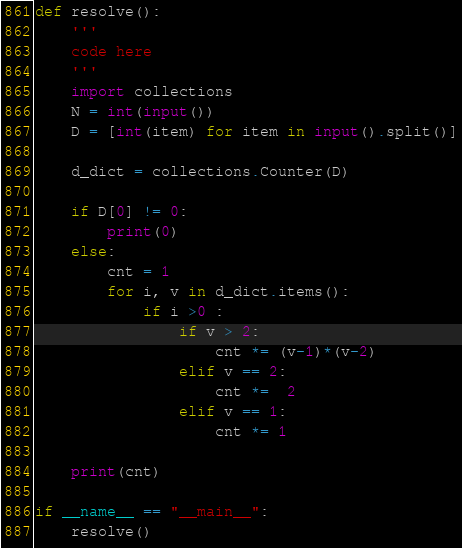<code> <loc_0><loc_0><loc_500><loc_500><_Python_>def resolve():
    '''
    code here
    '''
    import collections
    N = int(input())
    D = [int(item) for item in input().split()]

    d_dict = collections.Counter(D)

    if D[0] != 0:
        print(0)
    else:
        cnt = 1
        for i, v in d_dict.items():
            if i >0 :
                if v > 2:
                    cnt *= (v-1)*(v-2)
                elif v == 2:
                    cnt *=  2
                elif v == 1:
                    cnt *= 1

    print(cnt)

if __name__ == "__main__":
    resolve()
</code> 